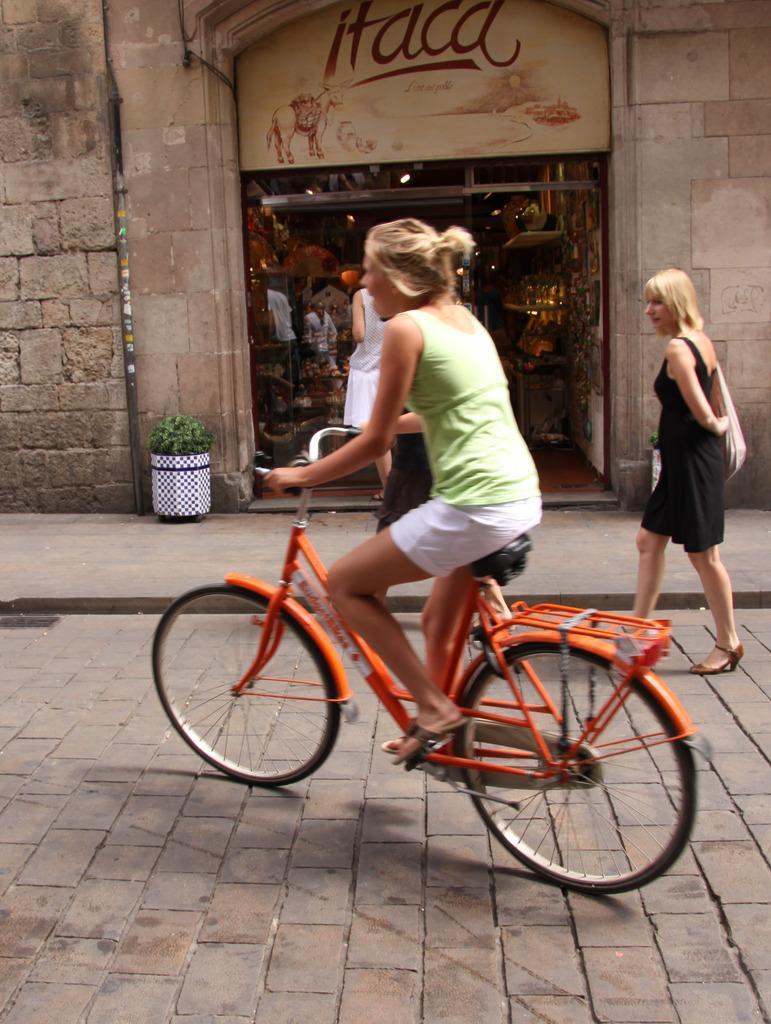In one or two sentences, can you explain what this image depicts? It is an image there is a cycle ,a woman is riding the cycle, beside her there is another woman who is walking ,in the background there is a store beside the store there is a wall. 